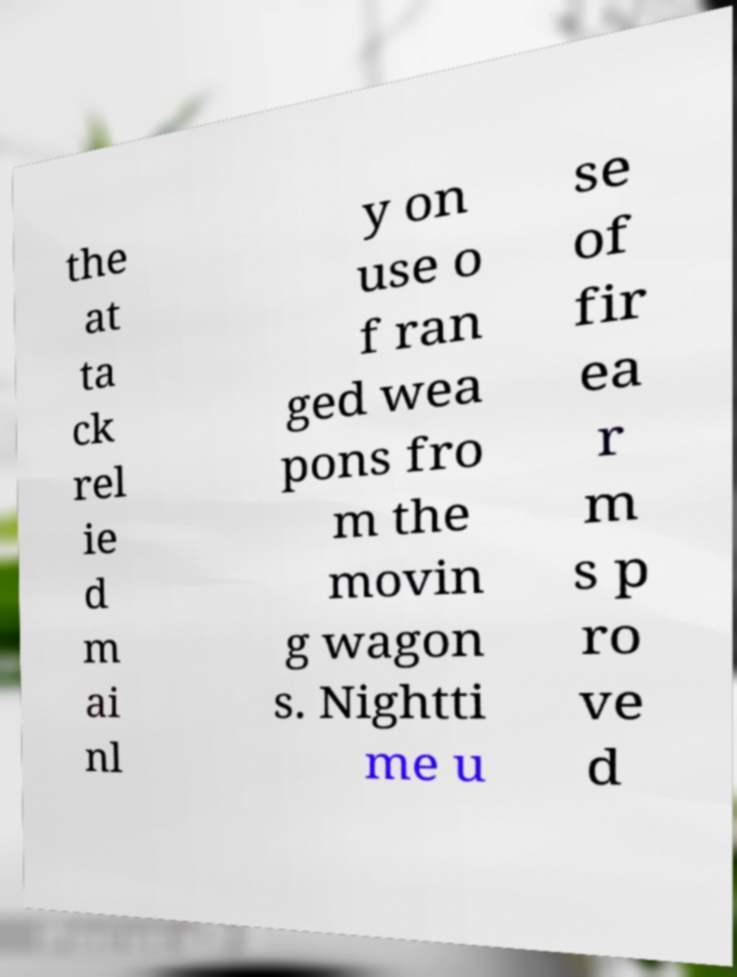For documentation purposes, I need the text within this image transcribed. Could you provide that? the at ta ck rel ie d m ai nl y on use o f ran ged wea pons fro m the movin g wagon s. Nightti me u se of fir ea r m s p ro ve d 